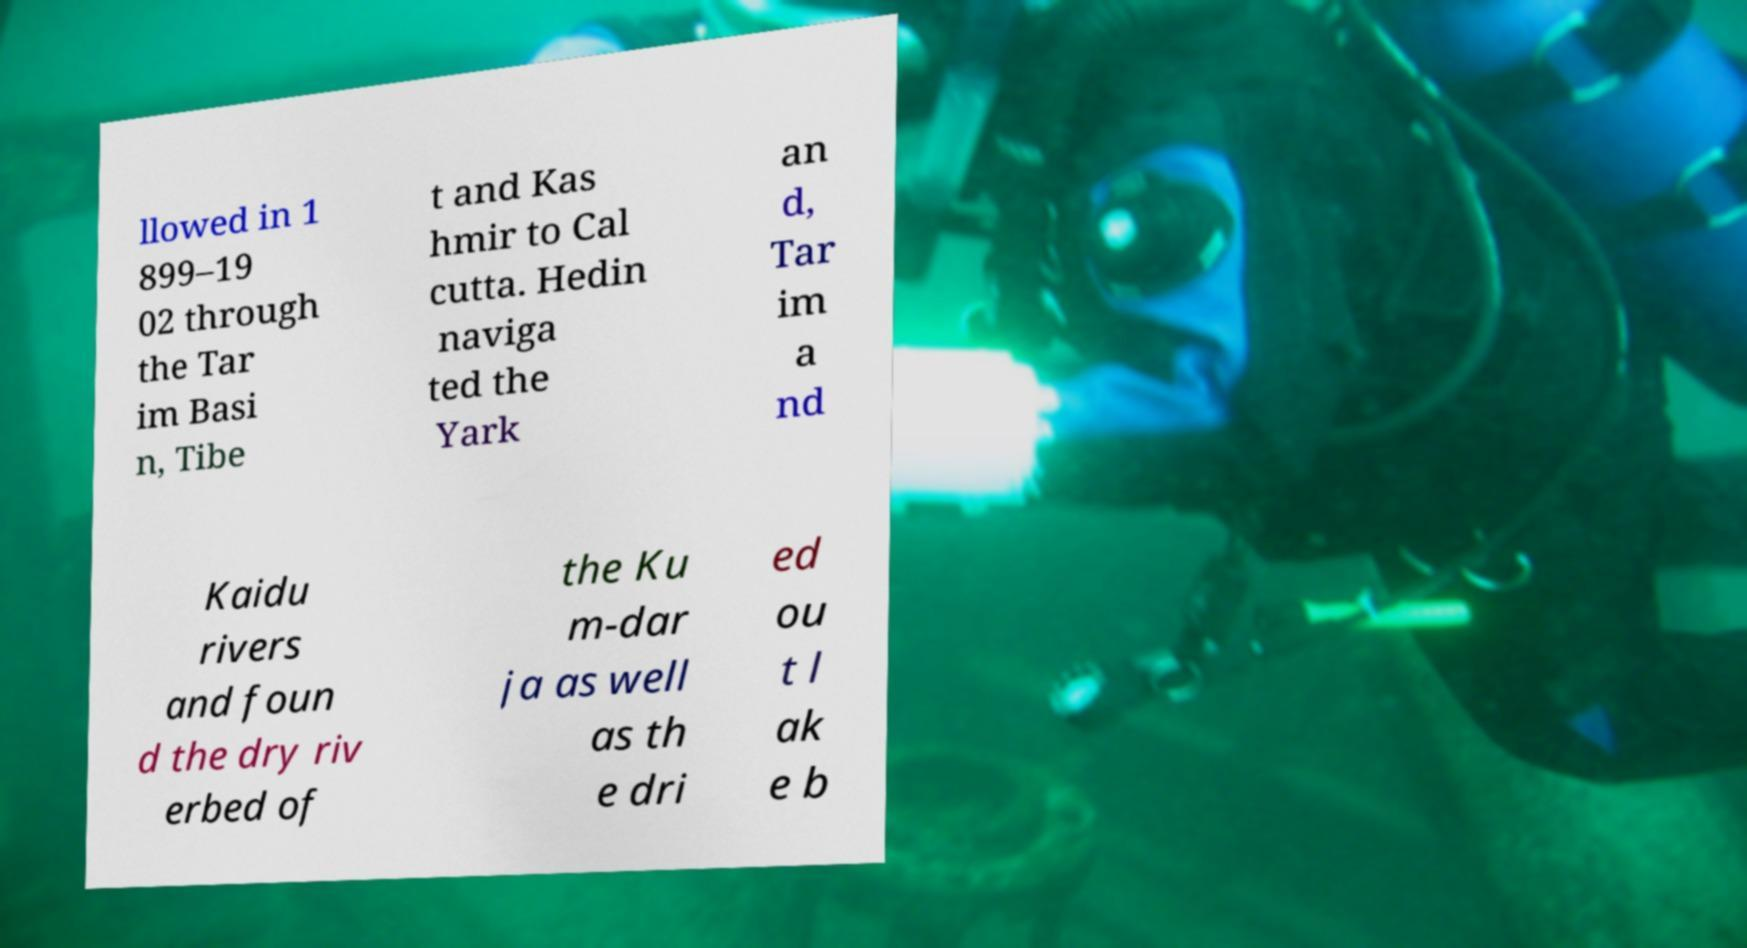Please identify and transcribe the text found in this image. llowed in 1 899–19 02 through the Tar im Basi n, Tibe t and Kas hmir to Cal cutta. Hedin naviga ted the Yark an d, Tar im a nd Kaidu rivers and foun d the dry riv erbed of the Ku m-dar ja as well as th e dri ed ou t l ak e b 